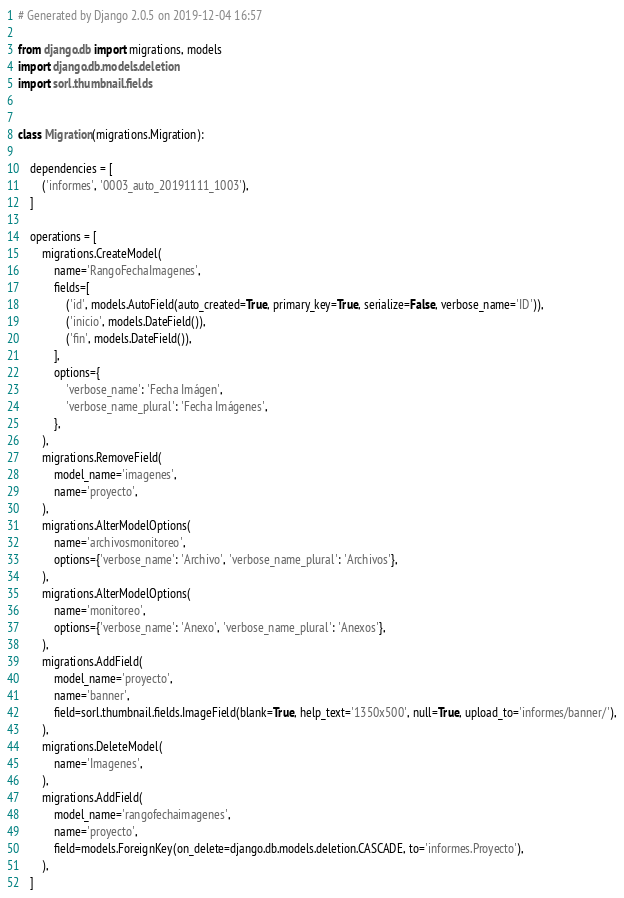<code> <loc_0><loc_0><loc_500><loc_500><_Python_># Generated by Django 2.0.5 on 2019-12-04 16:57

from django.db import migrations, models
import django.db.models.deletion
import sorl.thumbnail.fields


class Migration(migrations.Migration):

    dependencies = [
        ('informes', '0003_auto_20191111_1003'),
    ]

    operations = [
        migrations.CreateModel(
            name='RangoFechaImagenes',
            fields=[
                ('id', models.AutoField(auto_created=True, primary_key=True, serialize=False, verbose_name='ID')),
                ('inicio', models.DateField()),
                ('fin', models.DateField()),
            ],
            options={
                'verbose_name': 'Fecha Imágen',
                'verbose_name_plural': 'Fecha Imágenes',
            },
        ),
        migrations.RemoveField(
            model_name='imagenes',
            name='proyecto',
        ),
        migrations.AlterModelOptions(
            name='archivosmonitoreo',
            options={'verbose_name': 'Archivo', 'verbose_name_plural': 'Archivos'},
        ),
        migrations.AlterModelOptions(
            name='monitoreo',
            options={'verbose_name': 'Anexo', 'verbose_name_plural': 'Anexos'},
        ),
        migrations.AddField(
            model_name='proyecto',
            name='banner',
            field=sorl.thumbnail.fields.ImageField(blank=True, help_text='1350x500', null=True, upload_to='informes/banner/'),
        ),
        migrations.DeleteModel(
            name='Imagenes',
        ),
        migrations.AddField(
            model_name='rangofechaimagenes',
            name='proyecto',
            field=models.ForeignKey(on_delete=django.db.models.deletion.CASCADE, to='informes.Proyecto'),
        ),
    ]
</code> 